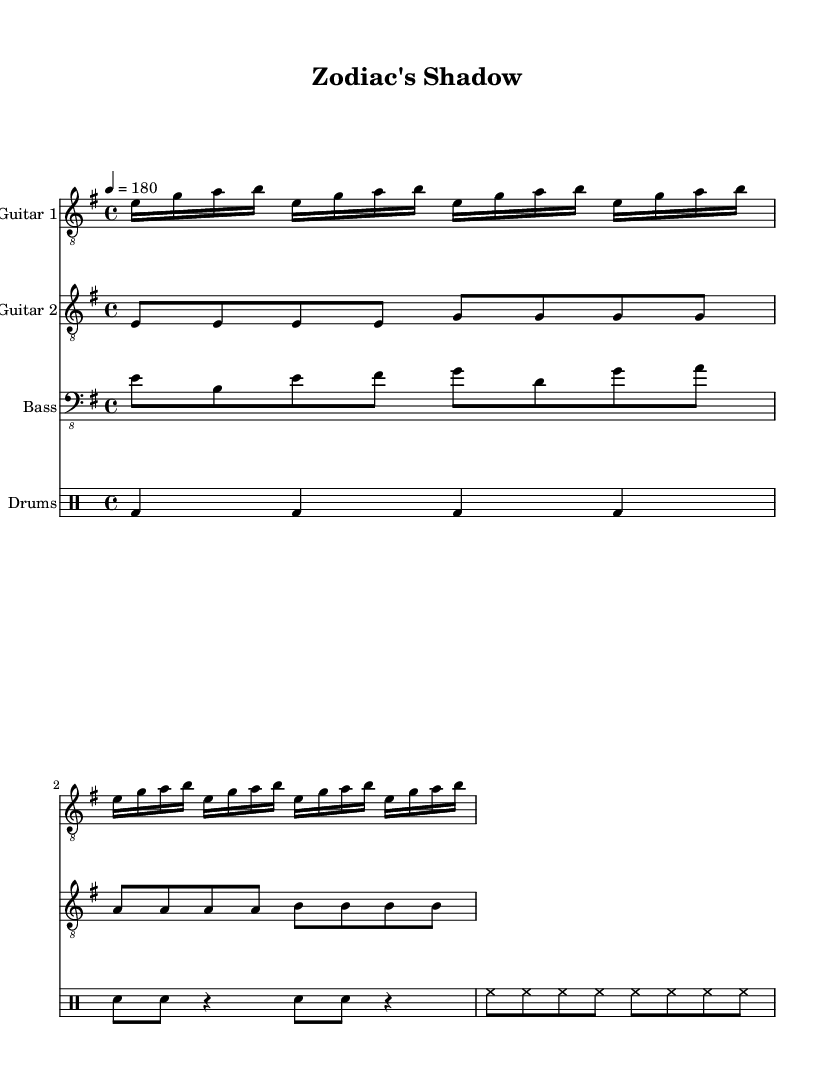What is the key signature of this music? The key signature is E minor, which has one sharp (F#). This is indicated at the beginning of the score, where the key signature is displayed.
Answer: E minor What is the time signature of this music? The time signature is 4/4, indicated at the beginning of the score. This means there are four beats in each measure and the quarter note gets one beat.
Answer: 4/4 What is the tempo marking for this piece? The tempo marking is 180 beats per minute, indicated by the "4 = 180" notated at the beginning of the score. This gives the speed at which the music should be played.
Answer: 180 How many measures are indicated in the guitar one part? The guitar one part shows four measures, as represented by the phrase repetition and the number of ending bars in the visual representation.
Answer: 4 What style of music does this piece represent? This piece represents the thrash metal genre, characterized by its fast tempo and aggressive guitar riffs, which can be inferred from the parts given and the overall context.
Answer: Thrash metal What instruments are featured in this score? The score features guitars, bass guitar, and drums, which are common in metal music. Each instrument is represented in its own designated staff, easily identifiable by instrument names.
Answer: Guitars, Bass, Drums What is the rhythmic pattern primarily used in the drums part? The rhythmic pattern in the drum part predominantly features alternating bass drums and snare with hi-hats, indicated by the specific rhythmic notation provided. This represents typical metal drumming patterns.
Answer: Alternating bass and snare 